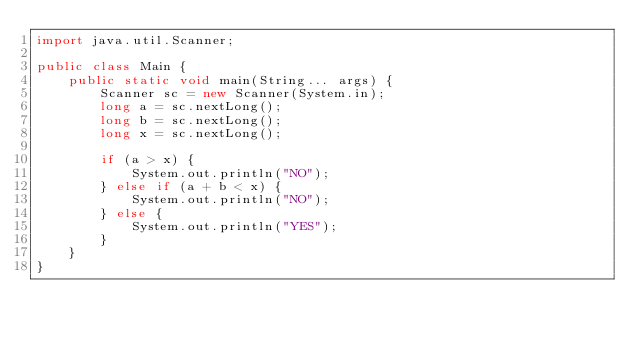<code> <loc_0><loc_0><loc_500><loc_500><_Java_>import java.util.Scanner;

public class Main {
	public static void main(String... args) {
		Scanner sc = new Scanner(System.in);
		long a = sc.nextLong();
		long b = sc.nextLong();
		long x = sc.nextLong();

		if (a > x) {
			System.out.println("NO");
		} else if (a + b < x) {
			System.out.println("NO");
		} else {
			System.out.println("YES");
		}
	}
}</code> 